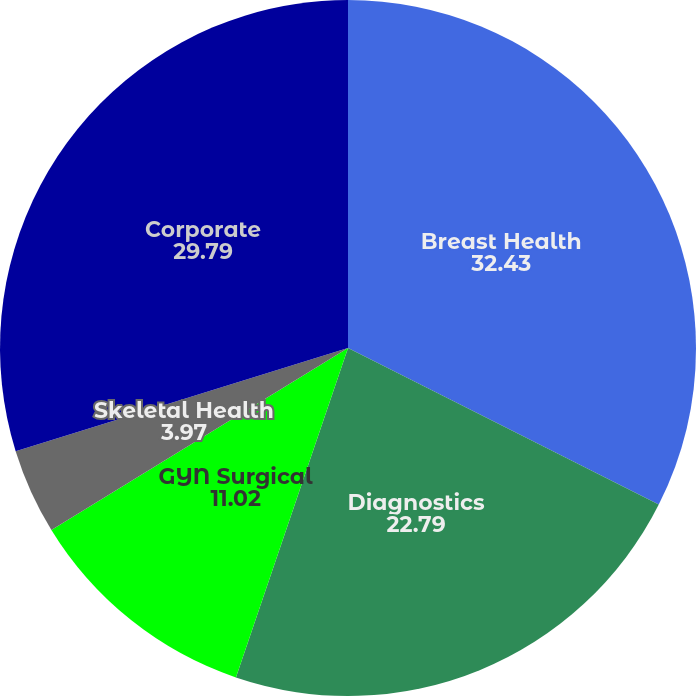<chart> <loc_0><loc_0><loc_500><loc_500><pie_chart><fcel>Breast Health<fcel>Diagnostics<fcel>GYN Surgical<fcel>Skeletal Health<fcel>Corporate<nl><fcel>32.43%<fcel>22.79%<fcel>11.02%<fcel>3.97%<fcel>29.79%<nl></chart> 